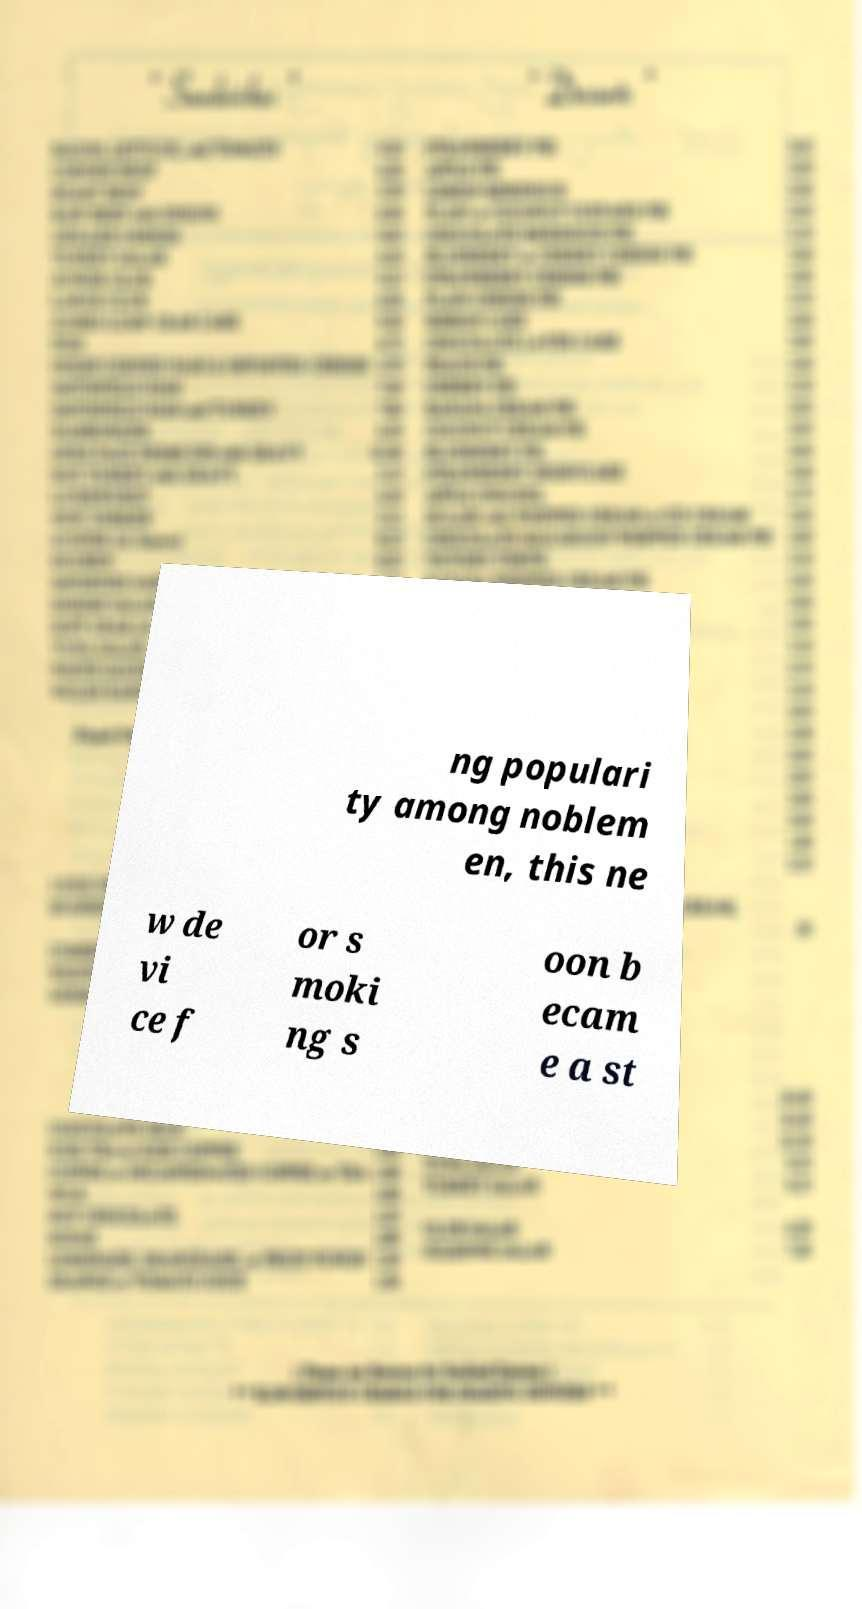I need the written content from this picture converted into text. Can you do that? ng populari ty among noblem en, this ne w de vi ce f or s moki ng s oon b ecam e a st 